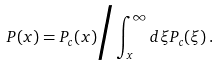<formula> <loc_0><loc_0><loc_500><loc_500>P ( x ) = P _ { c } ( x ) \Big / \int _ { x } ^ { \infty } d \xi P _ { c } ( \xi ) \, .</formula> 